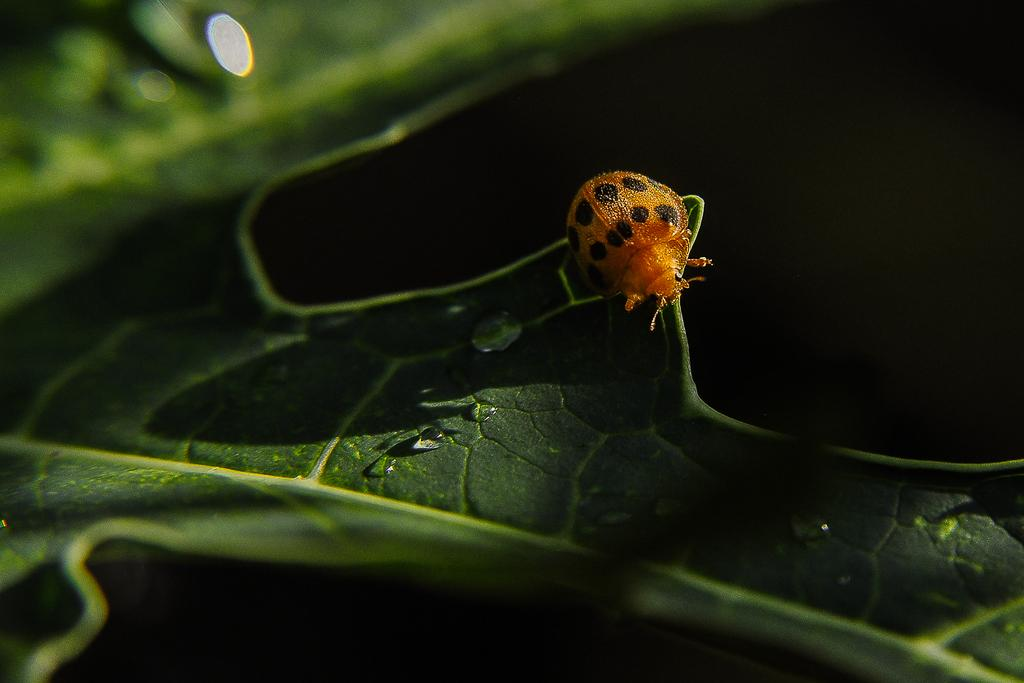What is present on the leaf in the image? There is a bug on the leaf in the image. Can you describe the setting of the image? The image features a bug on a leaf. What type of doctor is examining the bug in the image? There is no doctor present in the image; it only features a bug on a leaf. 